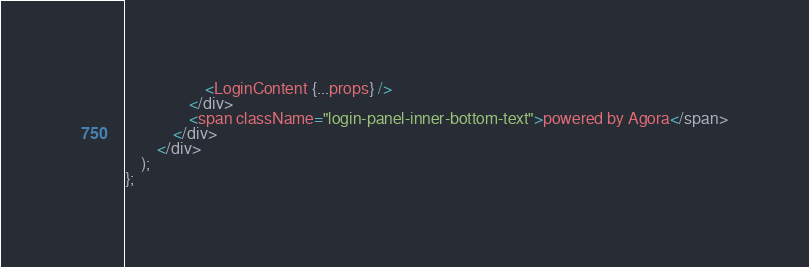<code> <loc_0><loc_0><loc_500><loc_500><_TypeScript_>                    <LoginContent {...props} />
                </div>
                <span className="login-panel-inner-bottom-text">powered by Agora</span>
            </div>
        </div>
    );
};
</code> 